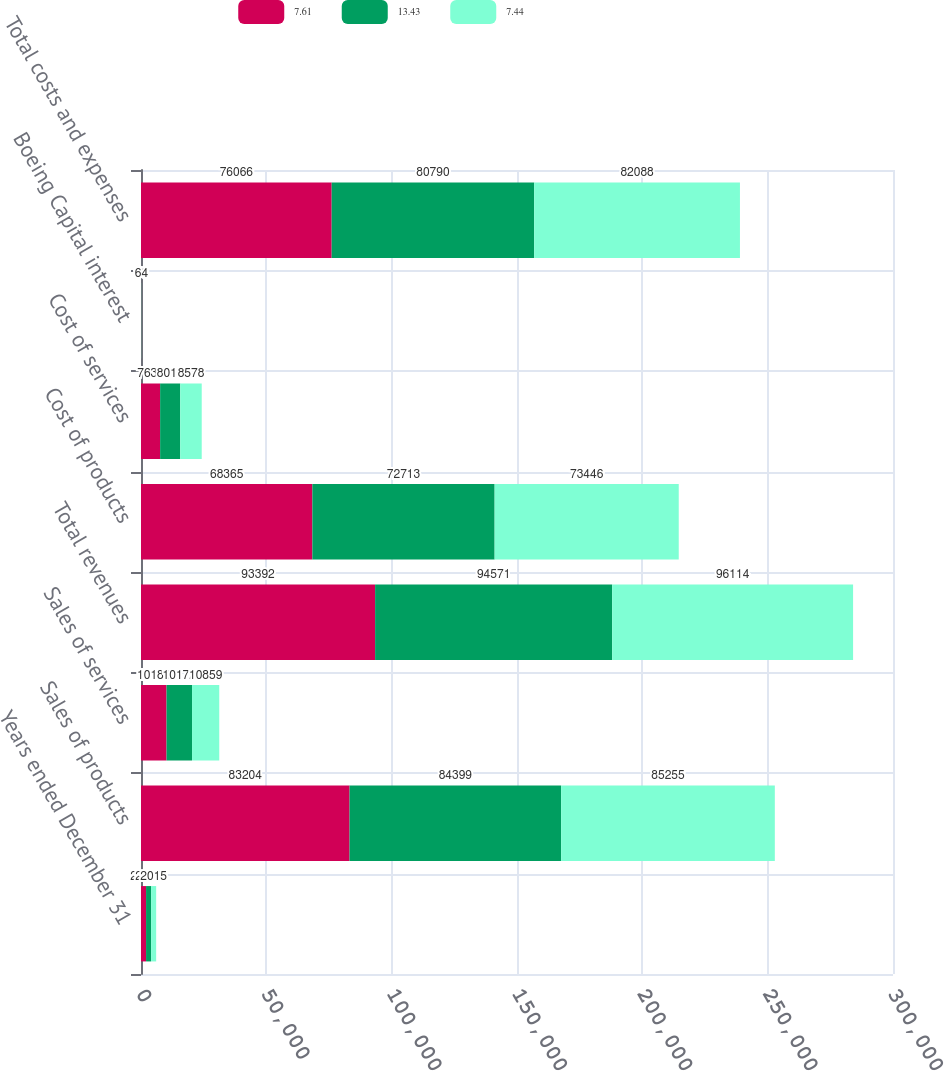Convert chart to OTSL. <chart><loc_0><loc_0><loc_500><loc_500><stacked_bar_chart><ecel><fcel>Years ended December 31<fcel>Sales of products<fcel>Sales of services<fcel>Total revenues<fcel>Cost of products<fcel>Cost of services<fcel>Boeing Capital interest<fcel>Total costs and expenses<nl><fcel>7.61<fcel>2017<fcel>83204<fcel>10188<fcel>93392<fcel>68365<fcel>7631<fcel>70<fcel>76066<nl><fcel>13.43<fcel>2016<fcel>84399<fcel>10172<fcel>94571<fcel>72713<fcel>8018<fcel>59<fcel>80790<nl><fcel>7.44<fcel>2015<fcel>85255<fcel>10859<fcel>96114<fcel>73446<fcel>8578<fcel>64<fcel>82088<nl></chart> 